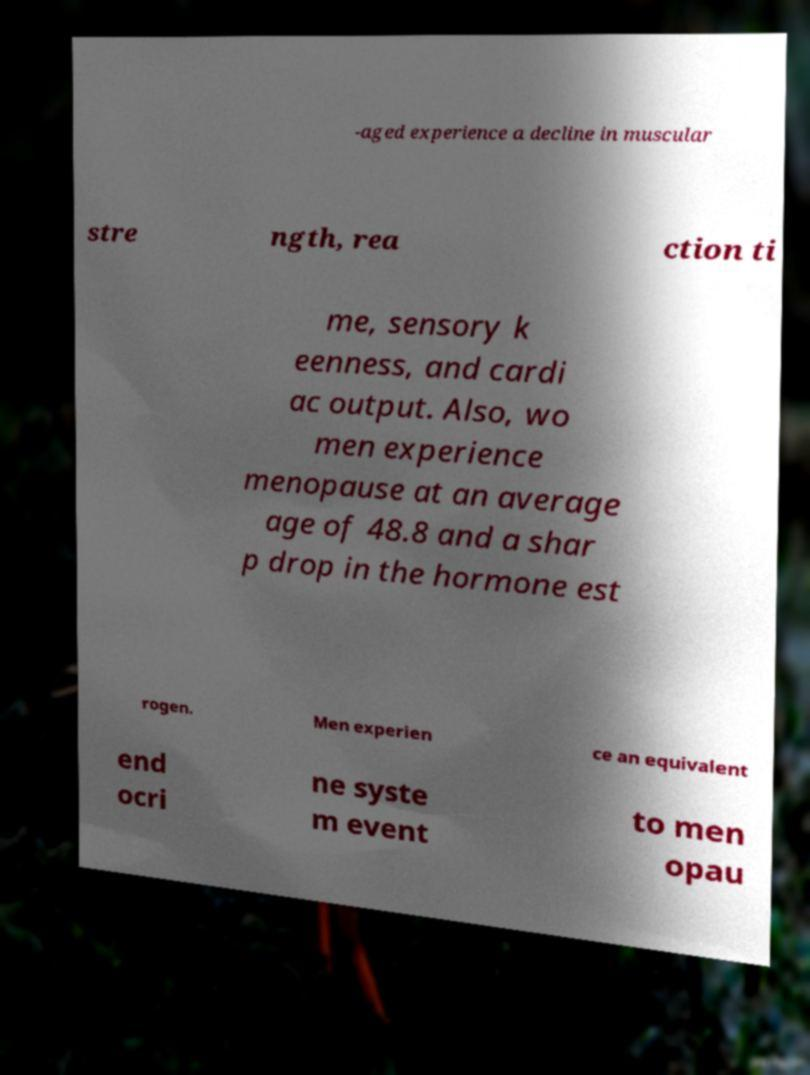Can you accurately transcribe the text from the provided image for me? -aged experience a decline in muscular stre ngth, rea ction ti me, sensory k eenness, and cardi ac output. Also, wo men experience menopause at an average age of 48.8 and a shar p drop in the hormone est rogen. Men experien ce an equivalent end ocri ne syste m event to men opau 